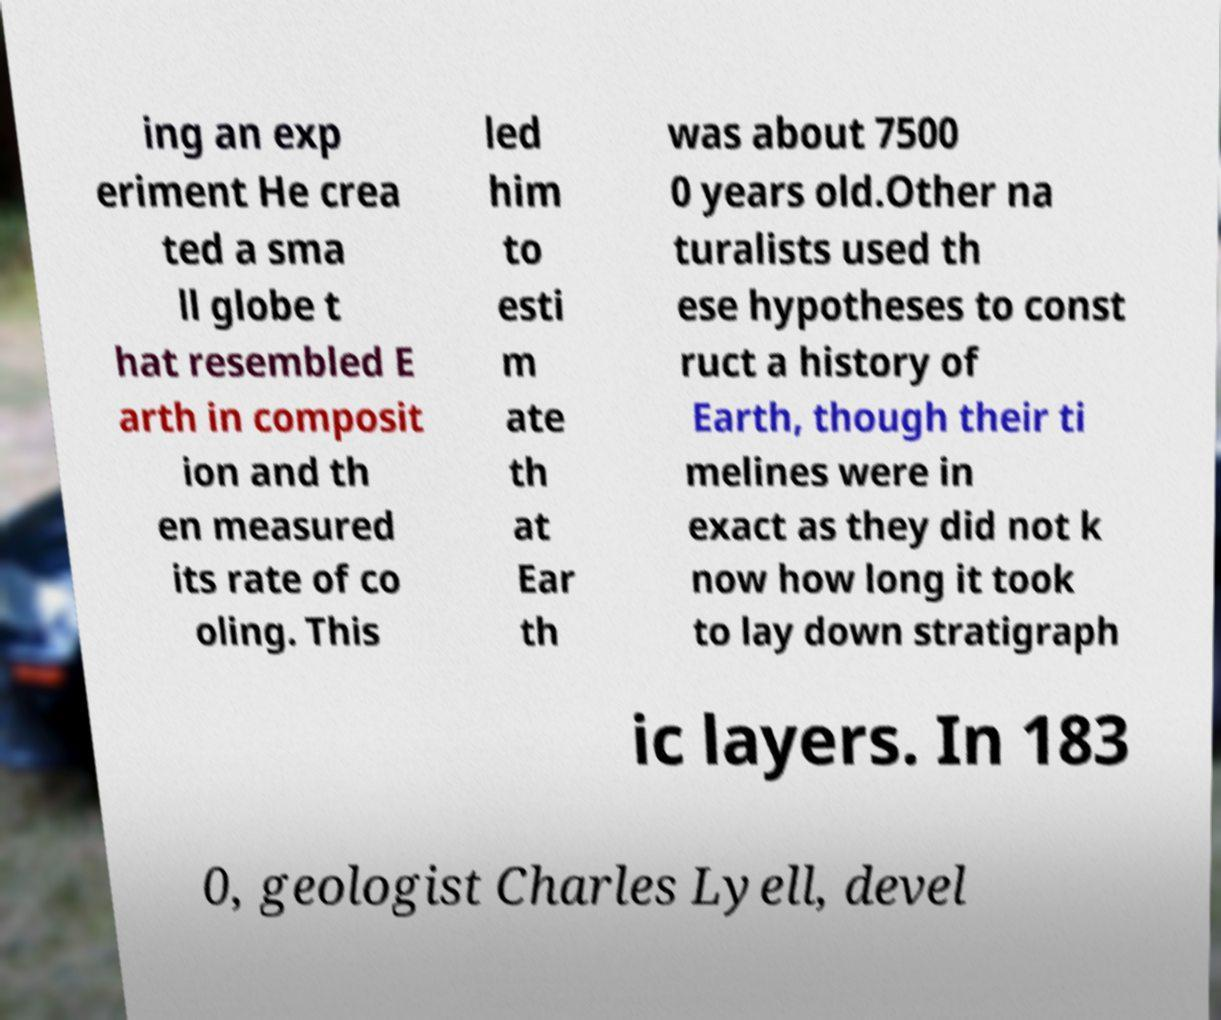Can you read and provide the text displayed in the image?This photo seems to have some interesting text. Can you extract and type it out for me? ing an exp eriment He crea ted a sma ll globe t hat resembled E arth in composit ion and th en measured its rate of co oling. This led him to esti m ate th at Ear th was about 7500 0 years old.Other na turalists used th ese hypotheses to const ruct a history of Earth, though their ti melines were in exact as they did not k now how long it took to lay down stratigraph ic layers. In 183 0, geologist Charles Lyell, devel 